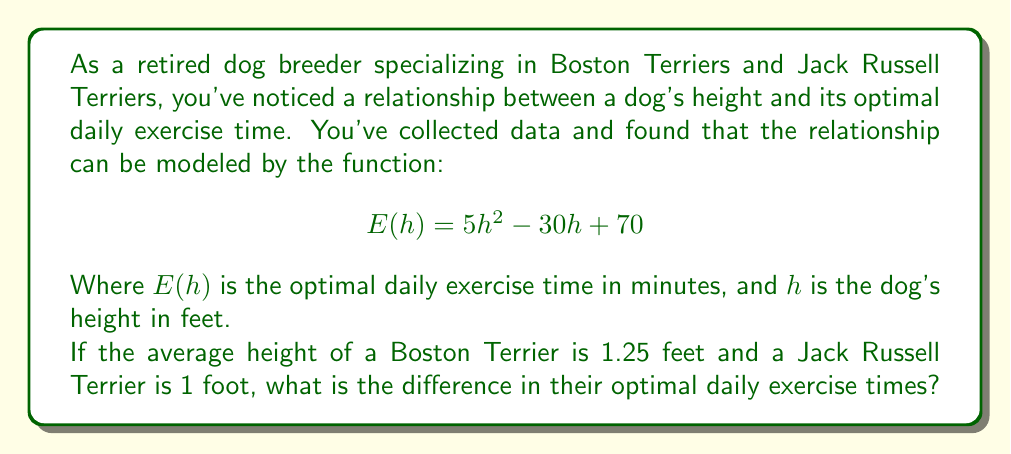Can you solve this math problem? To solve this problem, we need to follow these steps:

1. Calculate the optimal exercise time for a Boston Terrier:
   Let $h_B = 1.25$ feet (height of Boston Terrier)
   $$E(h_B) = 5(1.25)^2 - 30(1.25) + 70$$
   $$E(h_B) = 5(1.5625) - 37.5 + 70$$
   $$E(h_B) = 7.8125 - 37.5 + 70$$
   $$E(h_B) = 40.3125$$ minutes

2. Calculate the optimal exercise time for a Jack Russell Terrier:
   Let $h_J = 1$ foot (height of Jack Russell Terrier)
   $$E(h_J) = 5(1)^2 - 30(1) + 70$$
   $$E(h_J) = 5 - 30 + 70$$
   $$E(h_J) = 45$$ minutes

3. Calculate the difference in exercise times:
   Difference = $E(h_J) - E(h_B)$
   $$45 - 40.3125 = 4.6875$$ minutes

Therefore, the difference in optimal daily exercise times between a Jack Russell Terrier and a Boston Terrier is approximately 4.6875 minutes.
Answer: The difference in optimal daily exercise times between a Jack Russell Terrier and a Boston Terrier is approximately 4.6875 minutes, with the Jack Russell Terrier requiring more exercise time. 